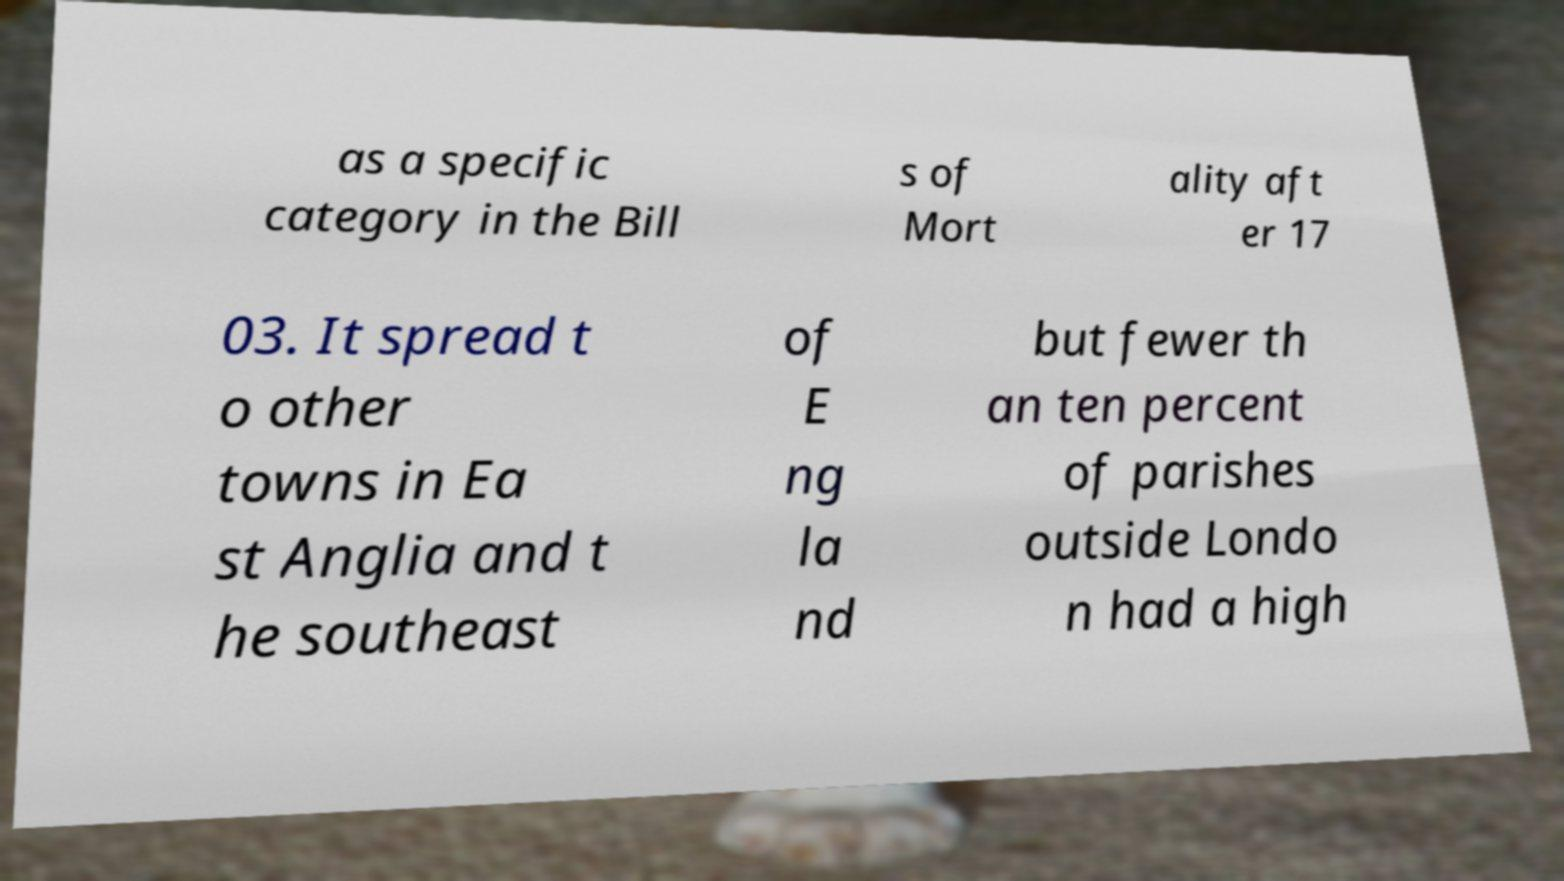I need the written content from this picture converted into text. Can you do that? as a specific category in the Bill s of Mort ality aft er 17 03. It spread t o other towns in Ea st Anglia and t he southeast of E ng la nd but fewer th an ten percent of parishes outside Londo n had a high 